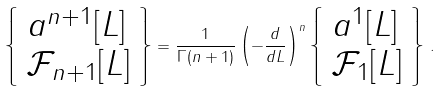Convert formula to latex. <formula><loc_0><loc_0><loc_500><loc_500>\left \{ \begin{array} { l } a ^ { n + 1 } [ L ] \\ { \mathcal { F } } _ { n + 1 } [ L ] \\ \end{array} \right \} = \frac { 1 } { \Gamma ( n + 1 ) } \left ( - \frac { d } { d L } \right ) ^ { n } \left \{ \begin{array} { l } a ^ { 1 } [ L ] \\ { \mathcal { F } } _ { 1 } [ L ] \\ \end{array} \right \} \, .</formula> 